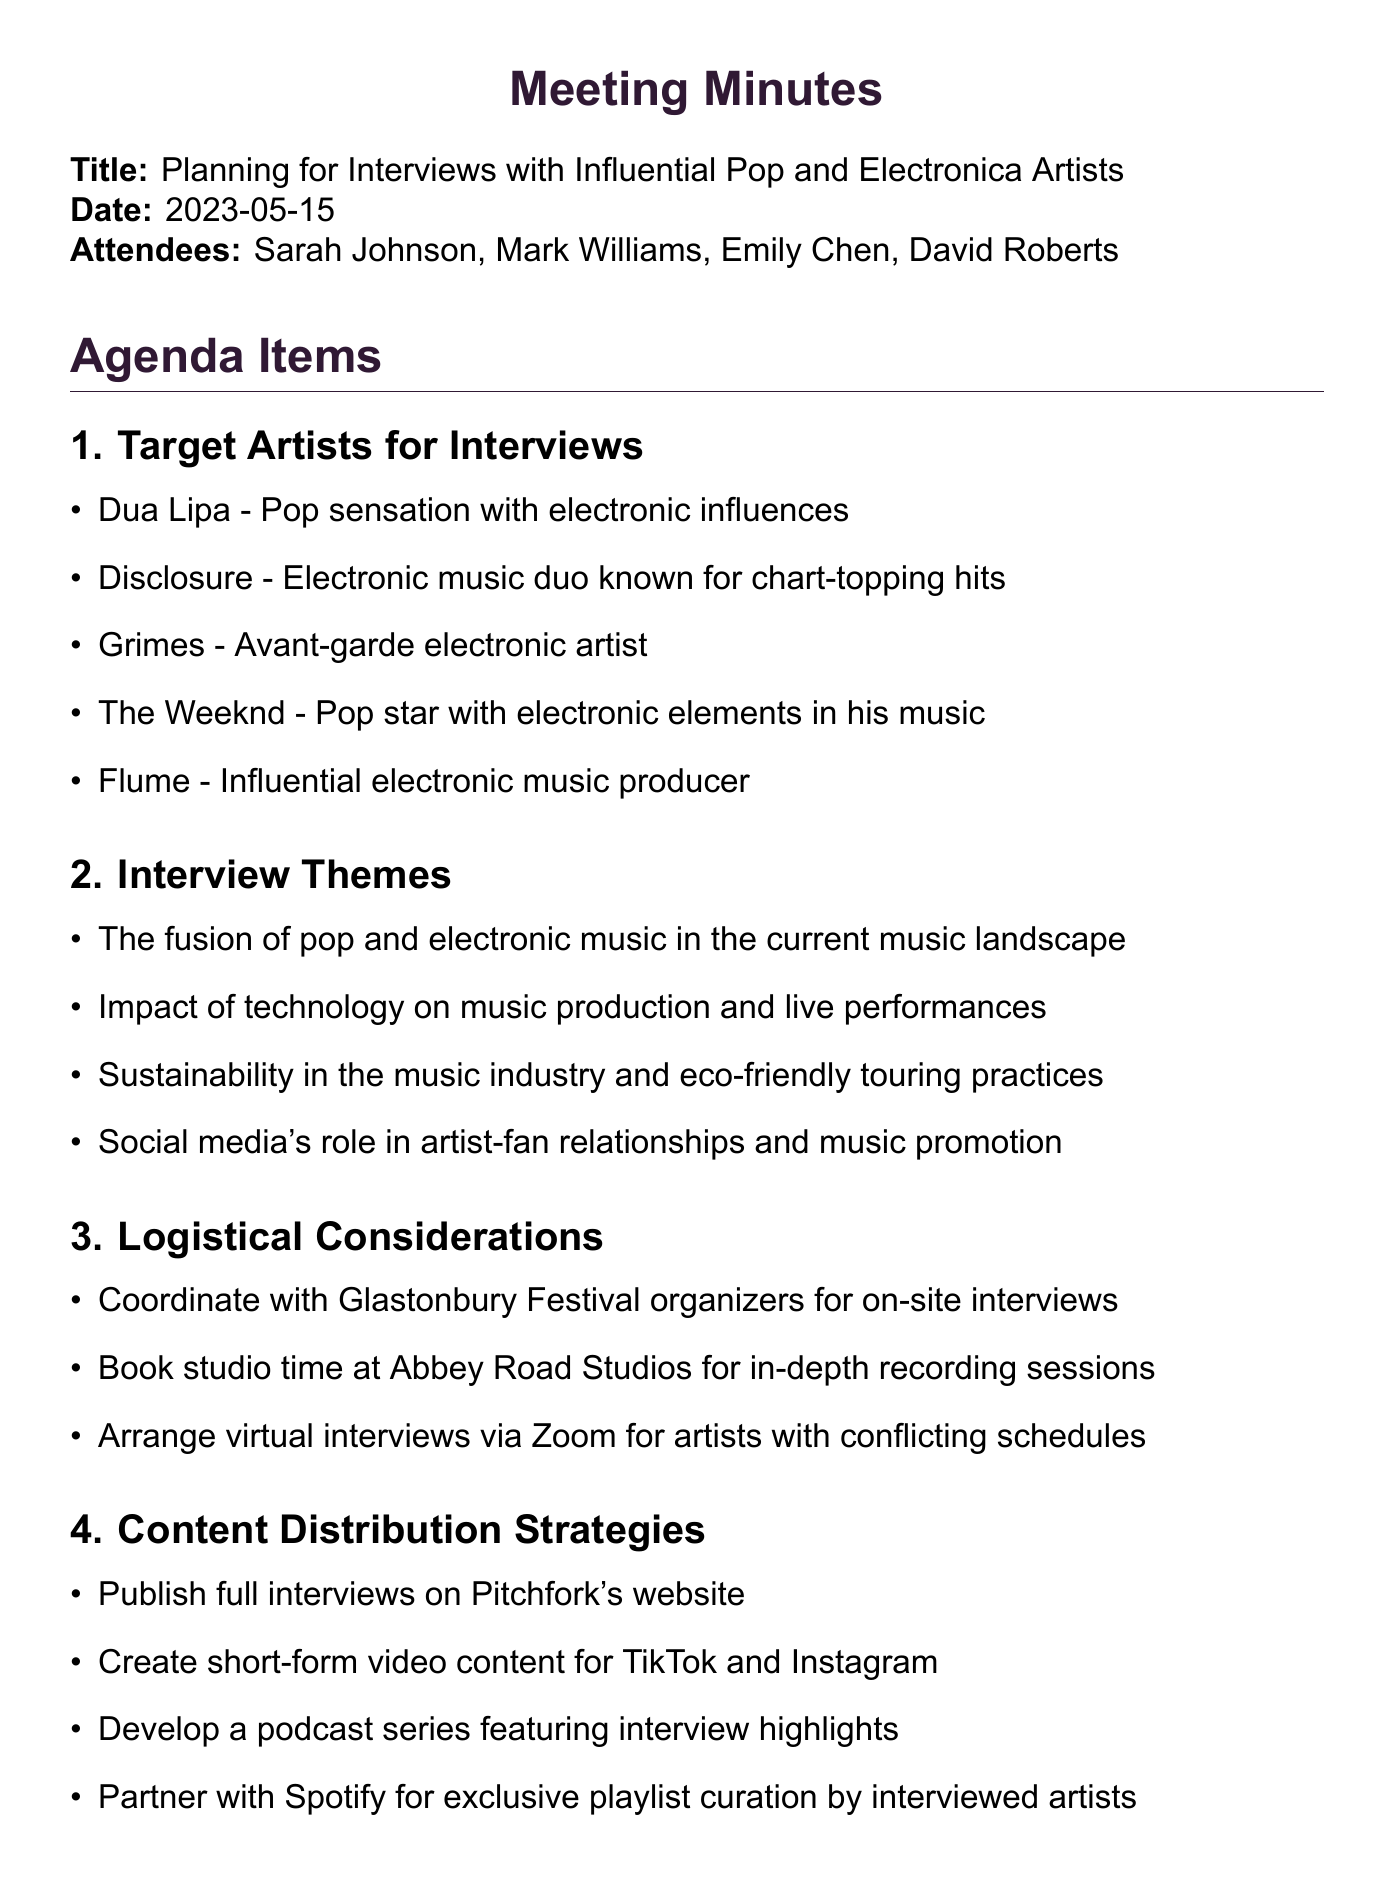What is the title of the meeting? The title of the meeting is the official name given to it, which is found at the beginning of the document.
Answer: Planning for Interviews with Influential Pop and Electronica Artists Who is responsible for drafting interview questions? The document specifies action items, where it is mentioned who is tasked with each item. Sarah is responsible for drafting interview questions for each artist.
Answer: Sarah What is the date of the meeting? The date is explicitly stated at the beginning of the document, providing the specific day when the meeting took place.
Answer: 2023-05-15 What are the themes for the interviews? The themes outlined in the document pertain to the subjects the interviews will cover, listed under the interview themes section.
Answer: The fusion of pop and electronic music in the current music landscape When is the completion date for artist outreach? The timeline provides specific deadlines for various tasks, including artist outreach, which is found in the timeline section.
Answer: June 1st Which artists are targeted for interviews? The document lists specific names under the agenda item for Target Artists for Interviews, detailing those who will be approached.
Answer: Dua Lipa How will the interviews be distributed? The content distribution strategies section outlines how the final content will be shared with the public, indicating the platforms for distribution.
Answer: Publish full interviews on Pitchfork's website What is the end publication target month for the feature article? The timeline section includes the expected month for the article's publication, indicating when it is planned to be released.
Answer: October What is the purpose of the meeting as indicated in the title? The meeting title suggests its main goal, which is to organize interviews with specific individuals in the music genre.
Answer: Planning for Interviews 